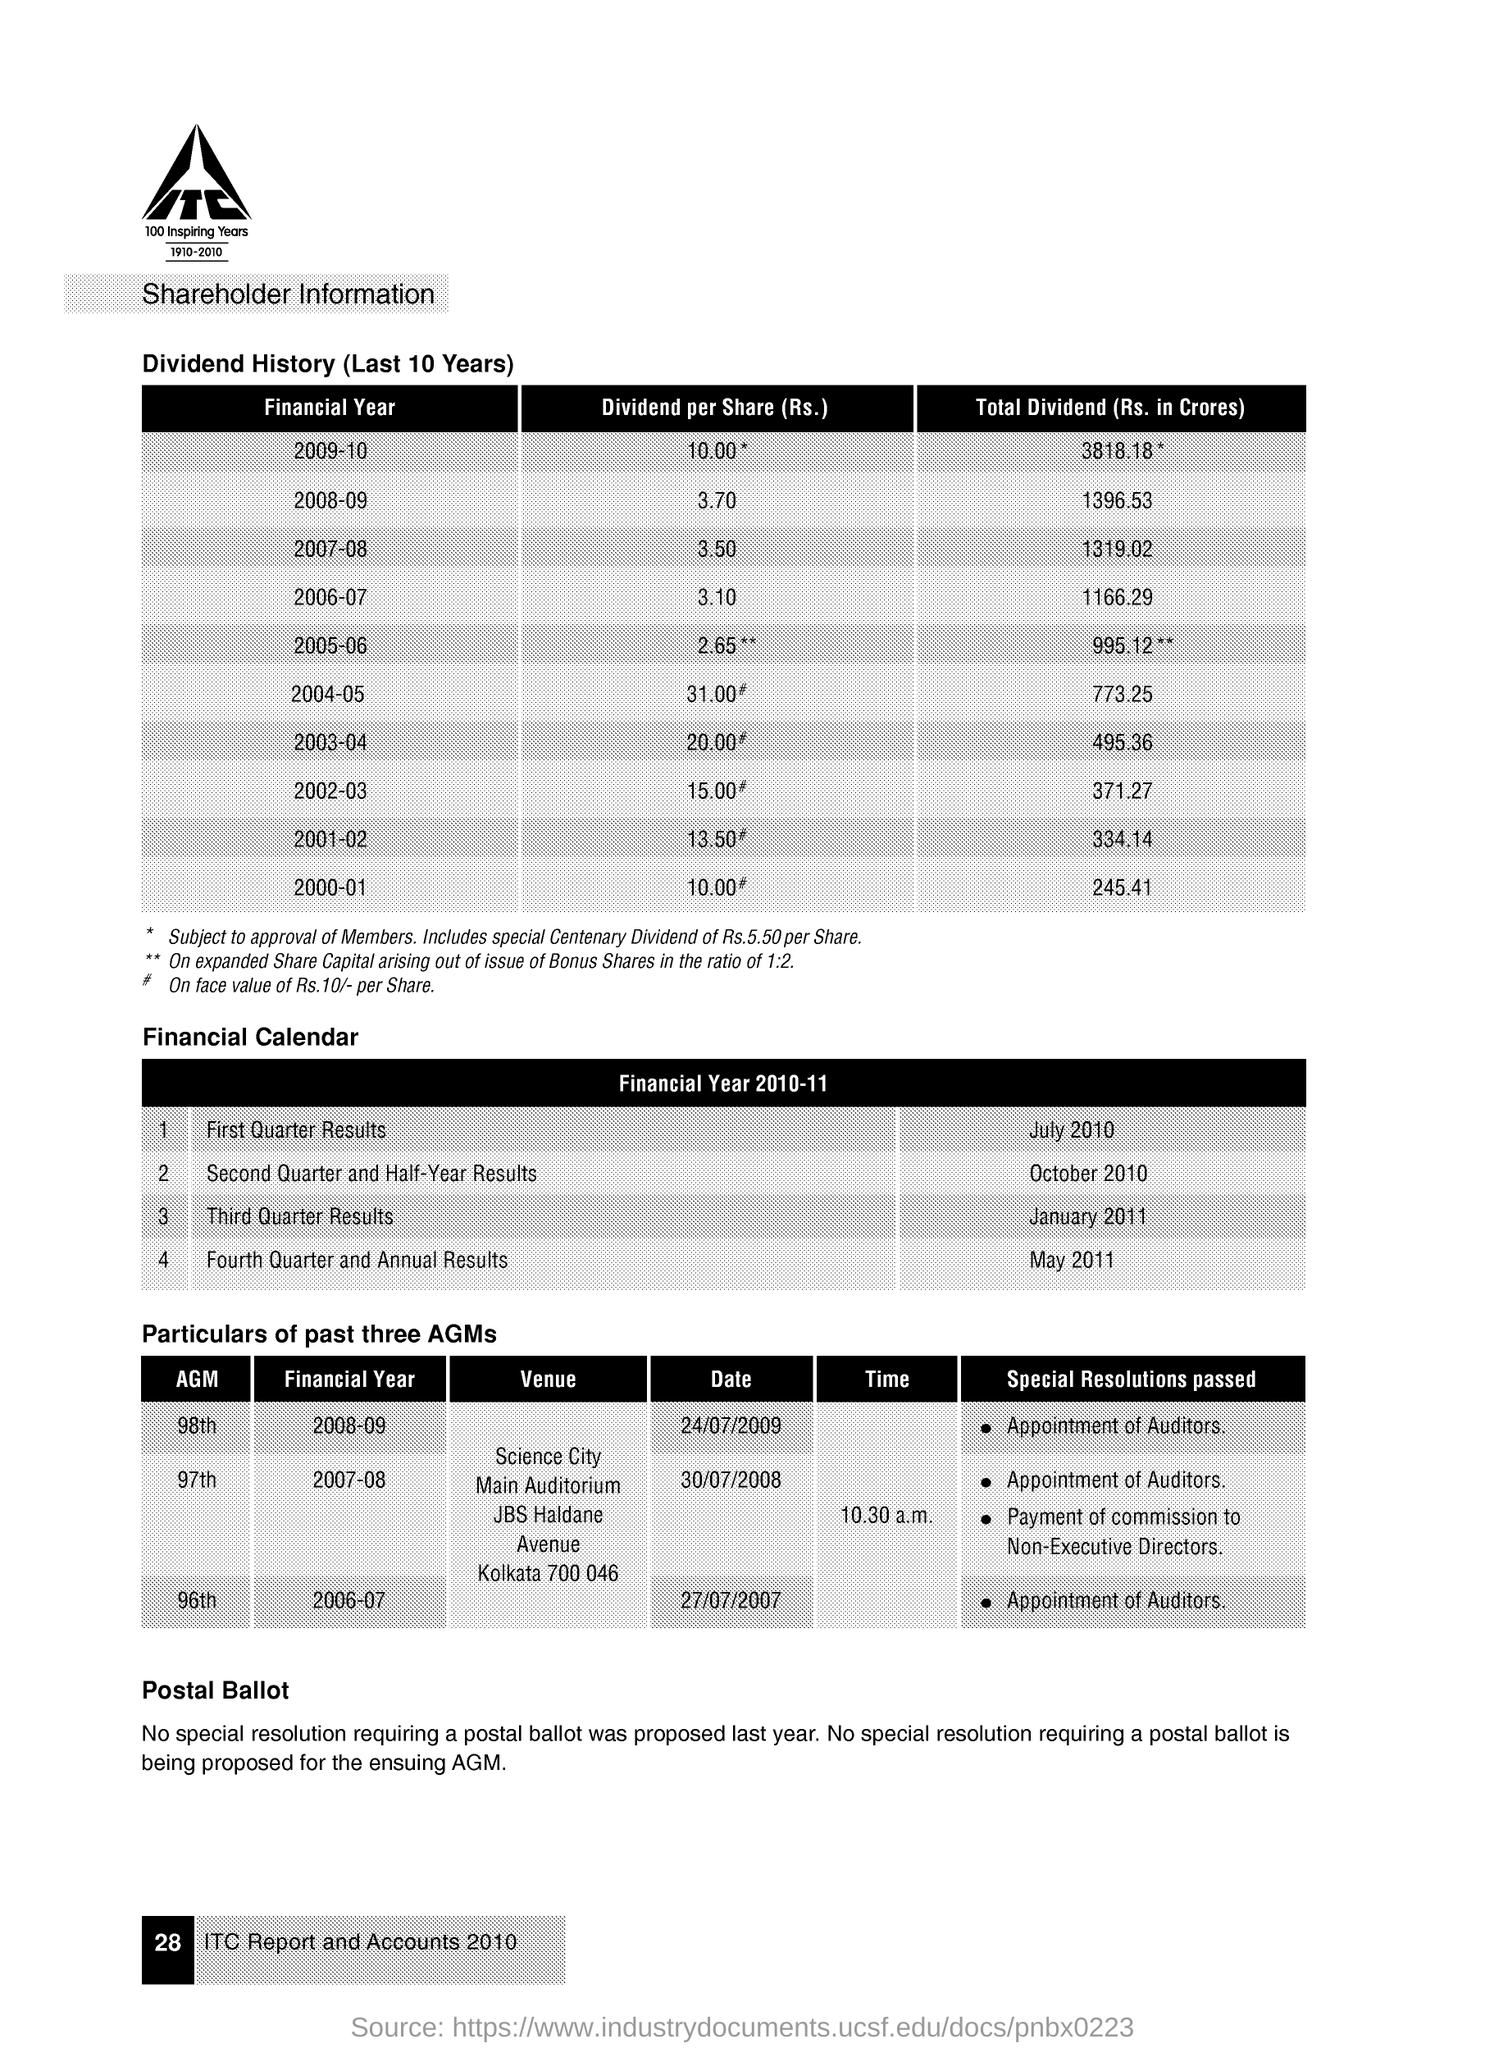What is the Dividend per Share(Rs.) for the Financial Year 2008-09?
 3.70 